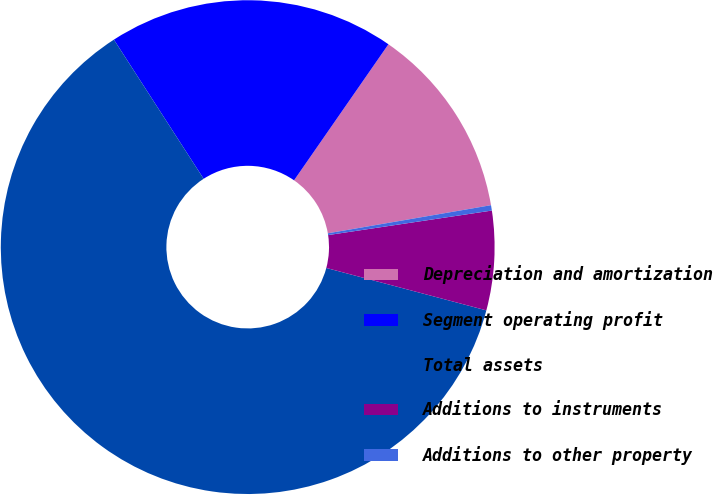Convert chart. <chart><loc_0><loc_0><loc_500><loc_500><pie_chart><fcel>Depreciation and amortization<fcel>Segment operating profit<fcel>Total assets<fcel>Additions to instruments<fcel>Additions to other property<nl><fcel>12.63%<fcel>18.77%<fcel>61.76%<fcel>6.49%<fcel>0.35%<nl></chart> 